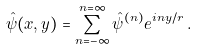Convert formula to latex. <formula><loc_0><loc_0><loc_500><loc_500>\hat { \psi } ( x , y ) = \sum _ { n = - \infty } ^ { n = \infty } \hat { \psi } ^ { ( n ) } e ^ { i n y / r } \, .</formula> 